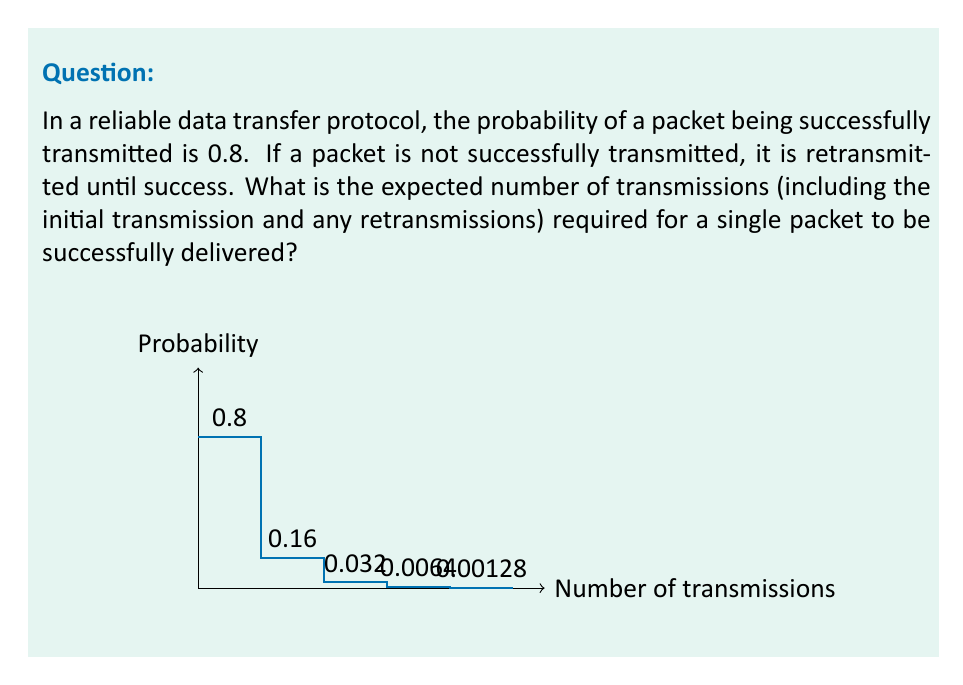What is the answer to this math problem? Let's approach this step-by-step:

1) First, we need to recognize that this scenario follows a geometric distribution. The geometric distribution models the number of trials needed to achieve the first success in a series of independent Bernoulli trials.

2) In a geometric distribution, the probability mass function is given by:
   $P(X = k) = (1-p)^{k-1} \cdot p$, where $p$ is the probability of success on each trial.

3) The expected value (mean) of a geometric distribution is given by:
   $E(X) = \frac{1}{p}$

4) In our case, $p = 0.8$ (the probability of successful transmission)

5) Therefore, the expected number of transmissions is:
   $E(X) = \frac{1}{0.8} = 1.25$

6) We can interpret this result as follows:
   - On average, we expect to need 1.25 transmissions per packet.
   - This includes the initial transmission and, on average, 0.25 retransmissions.

7) We can verify this intuitively:
   - 80% of the time (0.8), we succeed on the first try (1 transmission)
   - 16% of the time (0.8 * 0.2), we need 2 transmissions
   - 3.2% of the time (0.8 * 0.2 * 0.2), we need 3 transmissions
   - And so on...

   $E(X) = 1 \cdot 0.8 + 2 \cdot 0.16 + 3 \cdot 0.032 + ...$
   
   This infinite sum indeed converges to 1.25.
Answer: 1.25 transmissions 